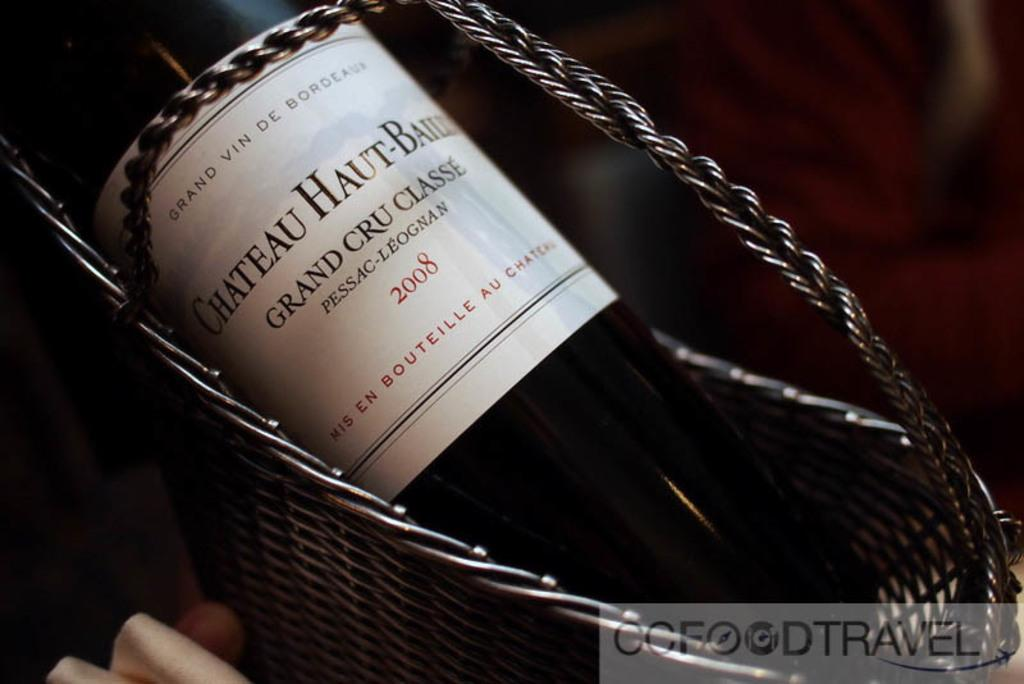<image>
Create a compact narrative representing the image presented. Bottle of chateau haut grand cru classe wine 